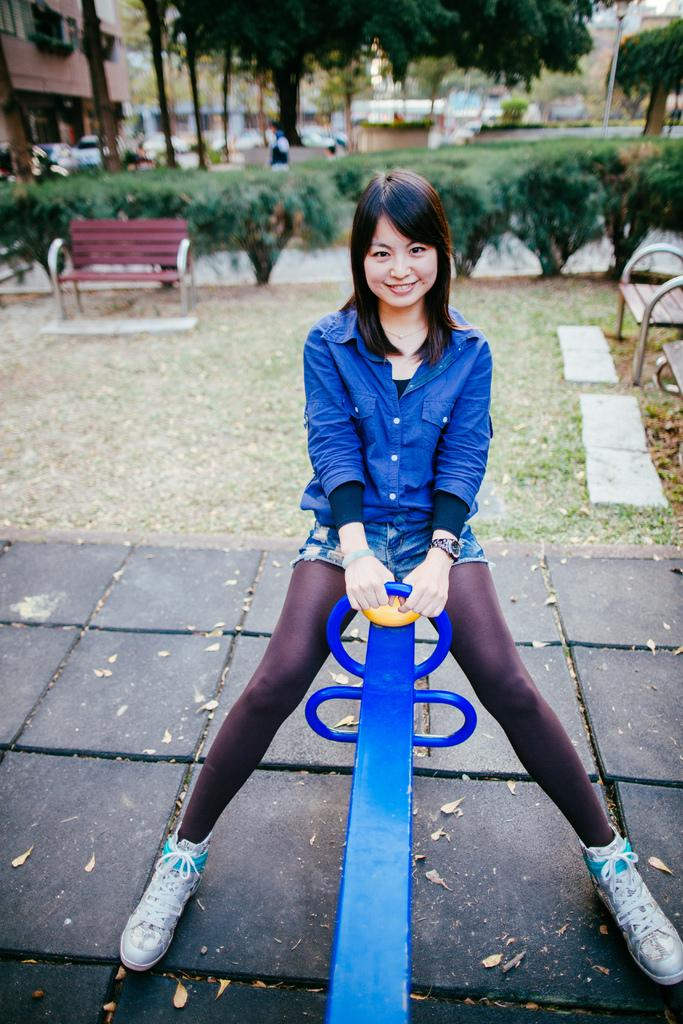Who is present in the image? There is a woman in the image. What is the woman doing in the image? The woman is sitting on a wooden plank. What is the woman's facial expression in the image? The woman is smiling. What type of vegetation can be seen in the image? There are trees visible in the image. What type of seating is present in the image? There are benches in the image. What type of path is visible in the image? There is a path in the image. What type of structure is present in the image? There is a building with windows in the image. What type of object is present in the image? There is a pole in the image. How would you describe the background of the image? The background is blurry. How many dogs are present in the image? There are no dogs present in the image. What type of care is the woman providing in the image? The image does not show the woman providing any care, as she is simply sitting on a wooden plank and smiling. What type of prose is written on the building in the image? There is no prose written on the building in the image; it only has windows. 